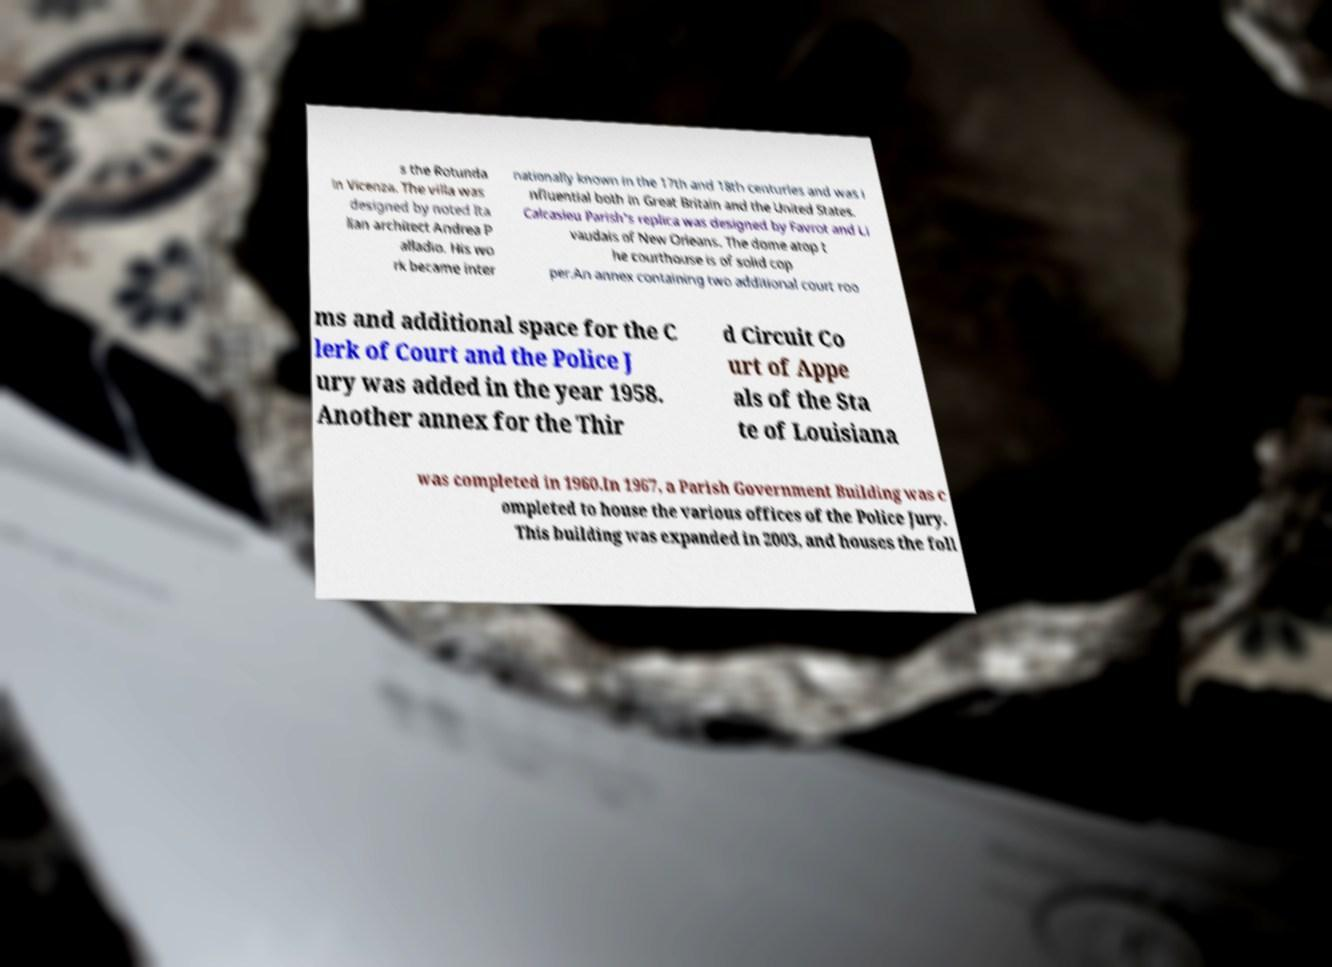Can you read and provide the text displayed in the image?This photo seems to have some interesting text. Can you extract and type it out for me? s the Rotunda in Vicenza. The villa was designed by noted Ita lian architect Andrea P alladio. His wo rk became inter nationally known in the 17th and 18th centuries and was i nfluential both in Great Britain and the United States. Calcasieu Parish's replica was designed by Favrot and Li vaudais of New Orleans. The dome atop t he courthouse is of solid cop per.An annex containing two additional court roo ms and additional space for the C lerk of Court and the Police J ury was added in the year 1958. Another annex for the Thir d Circuit Co urt of Appe als of the Sta te of Louisiana was completed in 1960.In 1967, a Parish Government Building was c ompleted to house the various offices of the Police Jury. This building was expanded in 2003, and houses the foll 